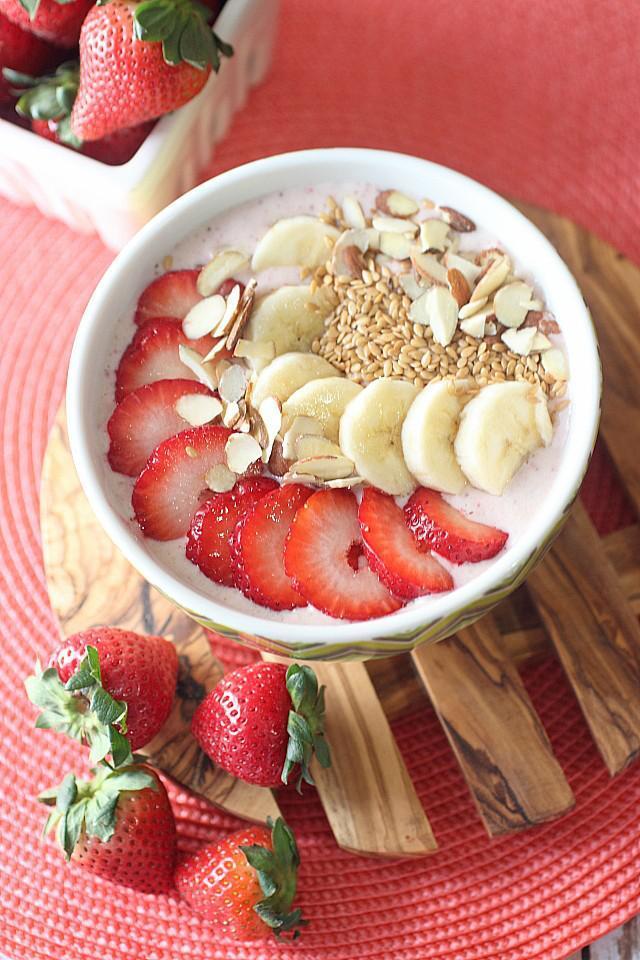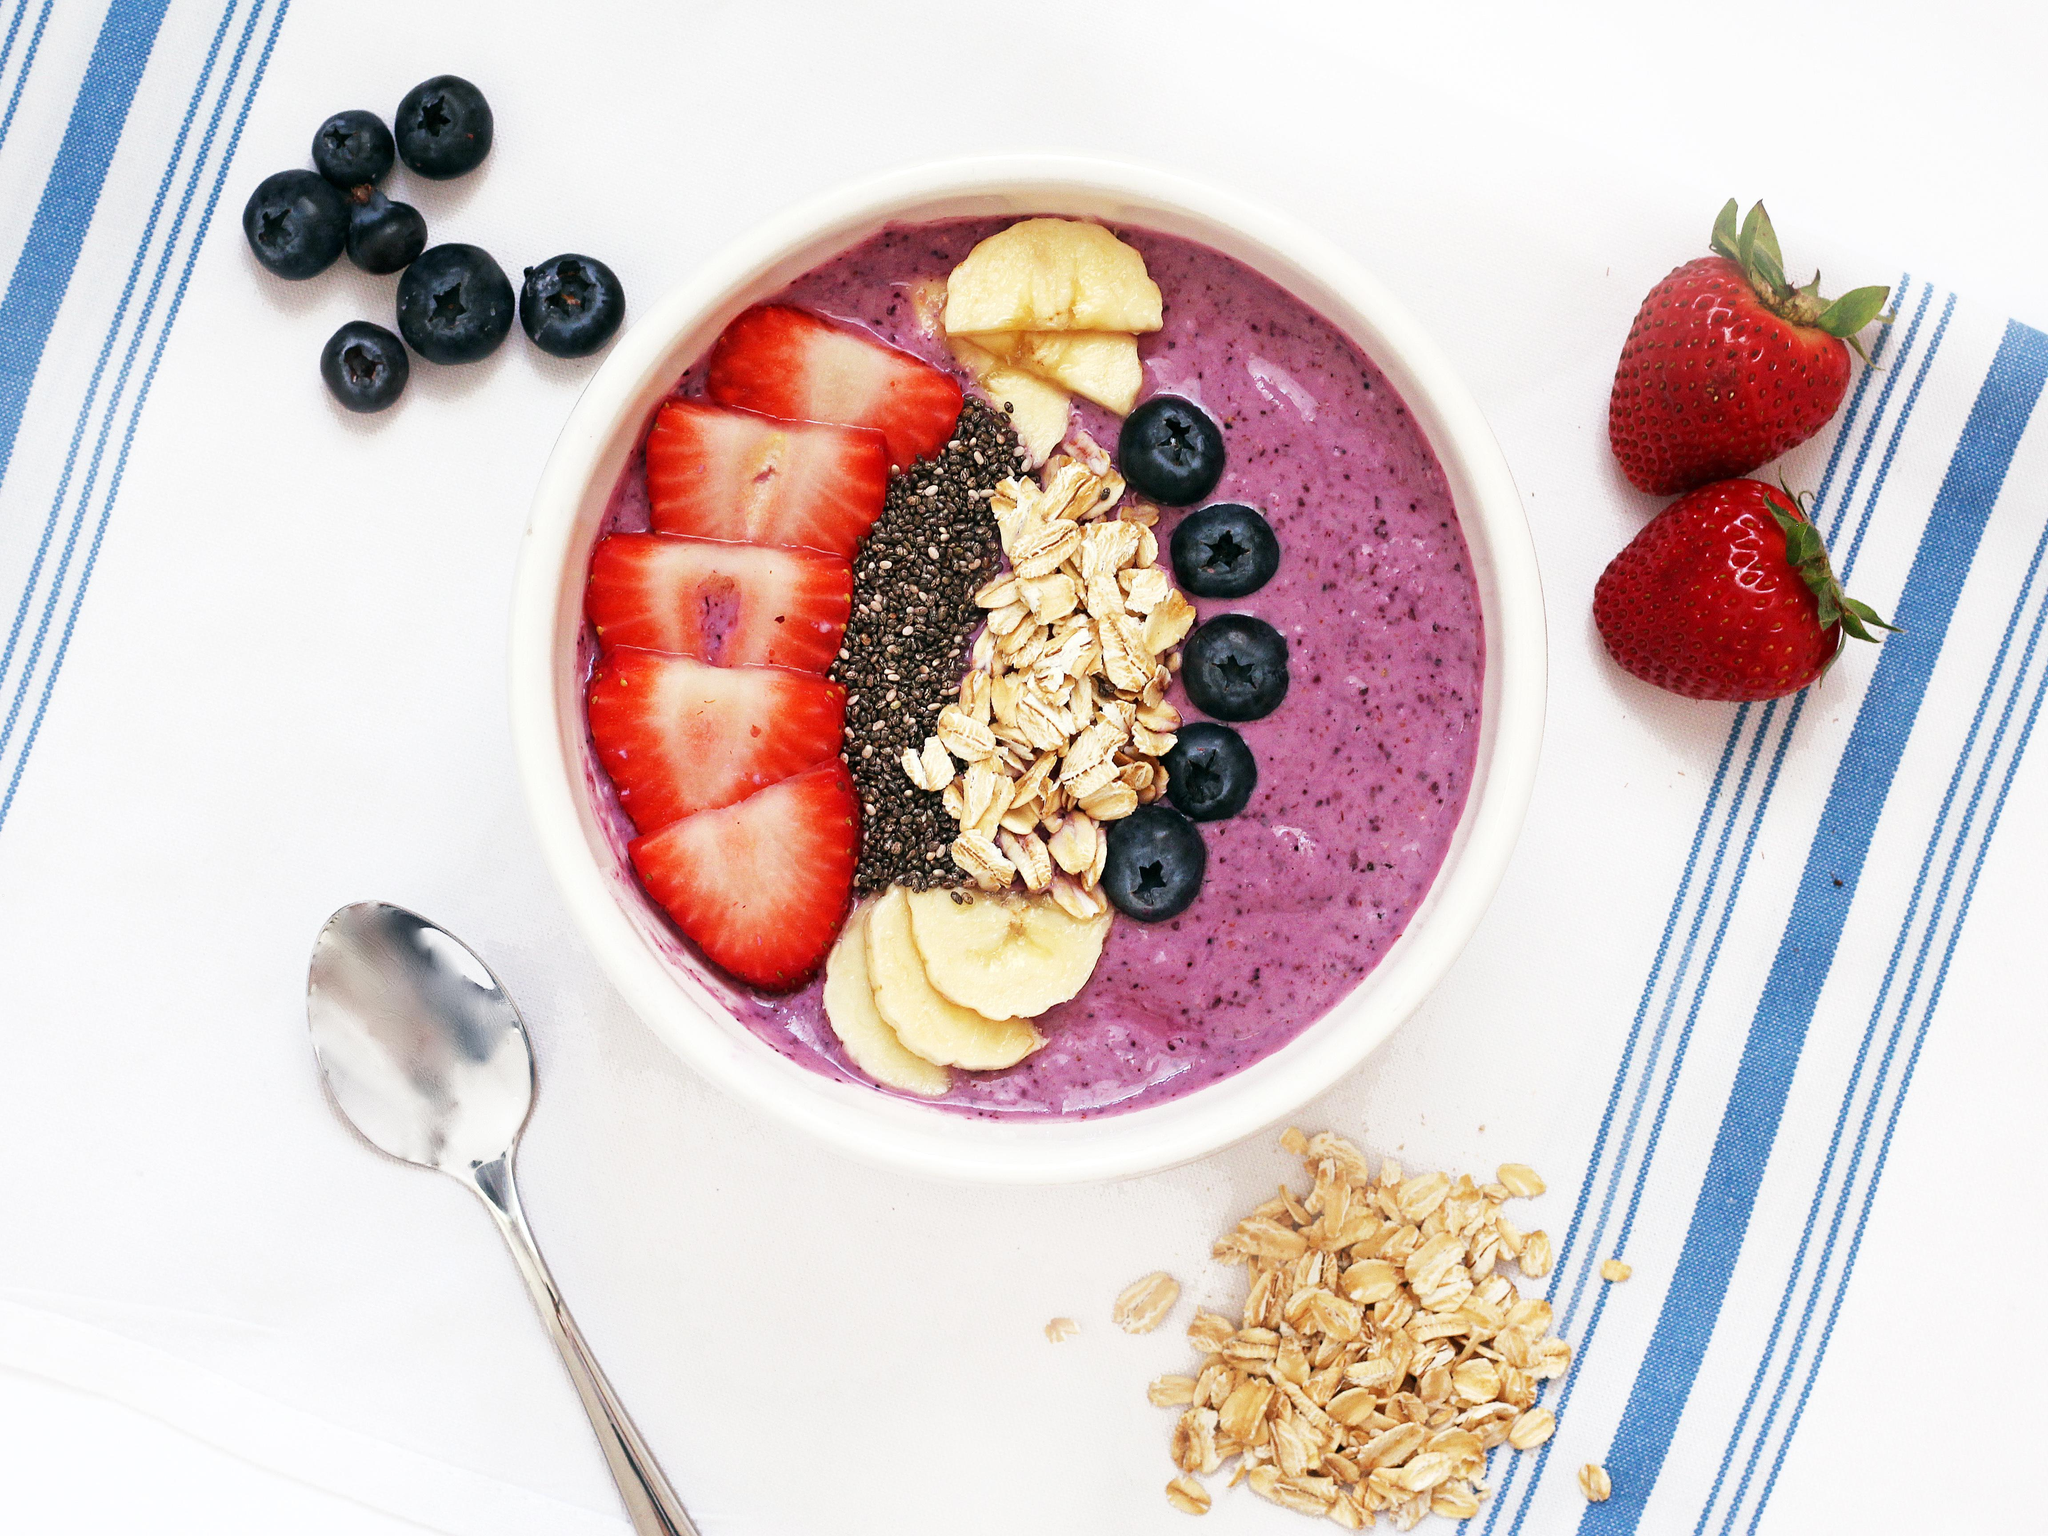The first image is the image on the left, the second image is the image on the right. Analyze the images presented: Is the assertion "There are at least two white bowls." valid? Answer yes or no. Yes. The first image is the image on the left, the second image is the image on the right. Examine the images to the left and right. Is the description "The combined images include a white bowl topped with blueberries and other ingredients, a square white container of fruit behind a white bowl, and a blue-striped white cloth next to a bowl." accurate? Answer yes or no. Yes. 